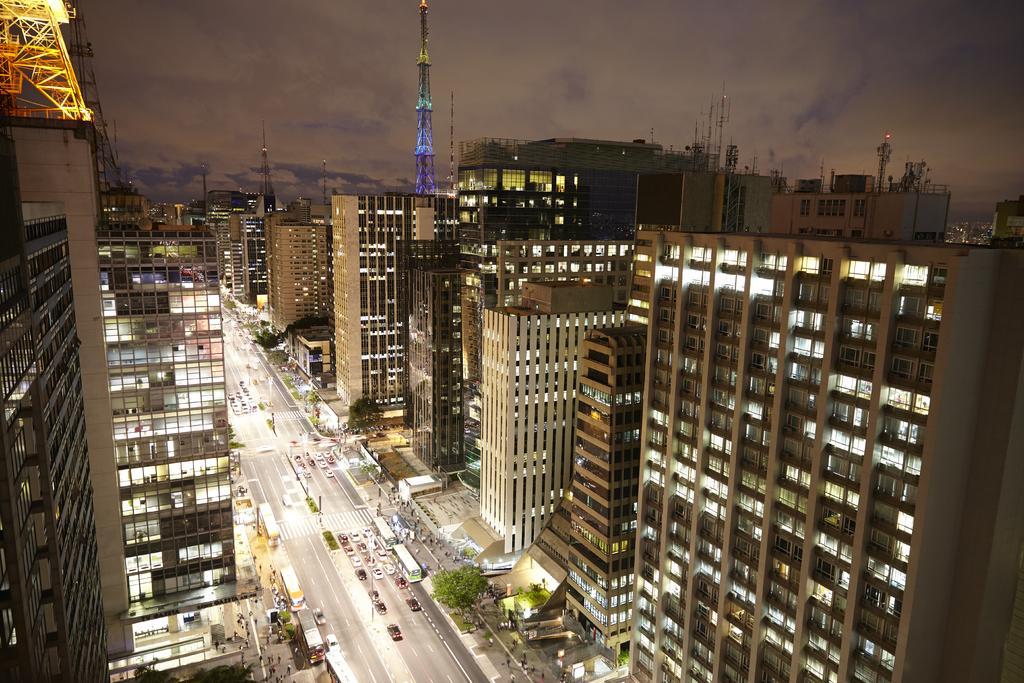Can you describe this image briefly? In this image I see number of buildings and I see the towers and over here I see the road, vehicles, trees and I can also see the lights and number of people and I see the sky. 